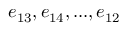Convert formula to latex. <formula><loc_0><loc_0><loc_500><loc_500>e _ { 1 3 } , e _ { 1 4 } , \dots , e _ { 1 2 }</formula> 